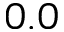<formula> <loc_0><loc_0><loc_500><loc_500>0 . 0</formula> 